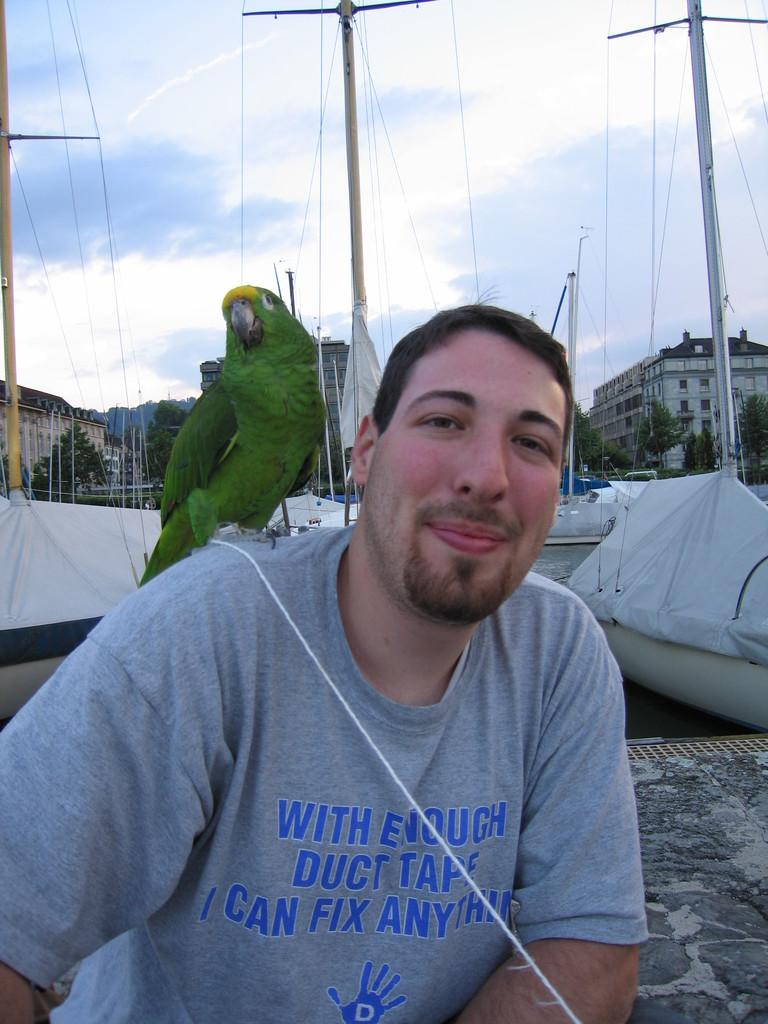Who or what is present in the image? There is a person and a parrot in the image. What can be seen in the background of the image? In the background of the image, there are boats, poles, a cloudy sky, buildings, trees, and other objects. Can you describe the setting of the image? The image appears to be set near a body of water, with various structures and natural elements visible in the background. What is the person's theory about the key in the image? There is no key present in the image, so it is not possible to discuss any theories about it. 